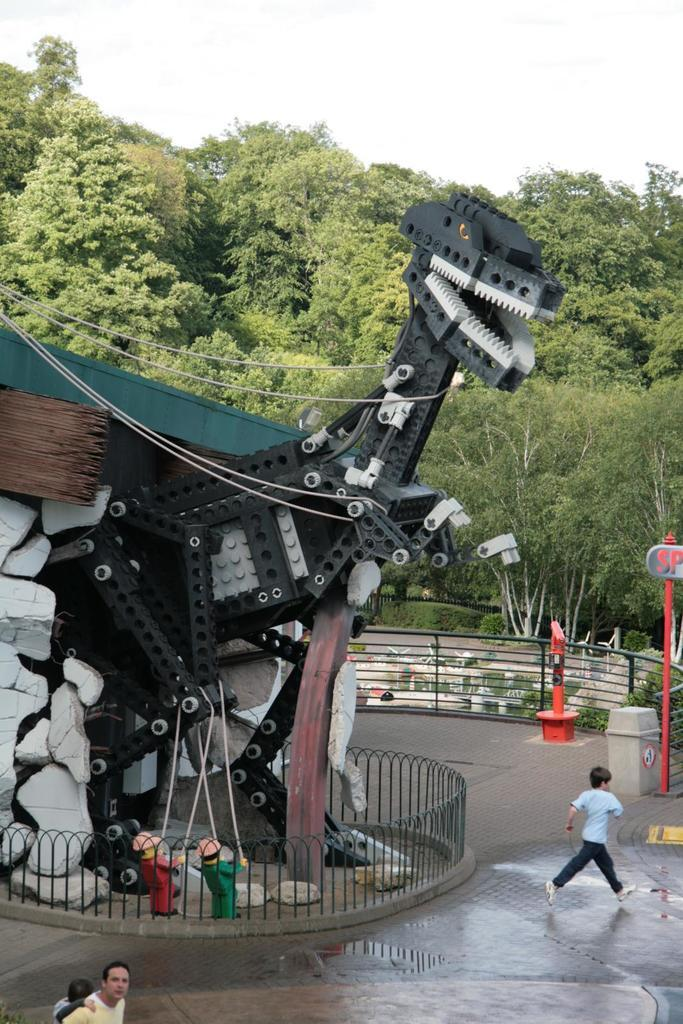Who or what can be seen in the image? There are people in the image. What type of object is present in the image? There is a model of a dinosaur in the image. What is located in the foreground of the image? There are plants in the foreground of the image. What is visible in the background of the image? There are trees and the sky in the background of the image. What direction is the cable pointing towards in the image? There is no cable present in the image. What type of glass object can be seen in the image? There is no glass object present in the image. 